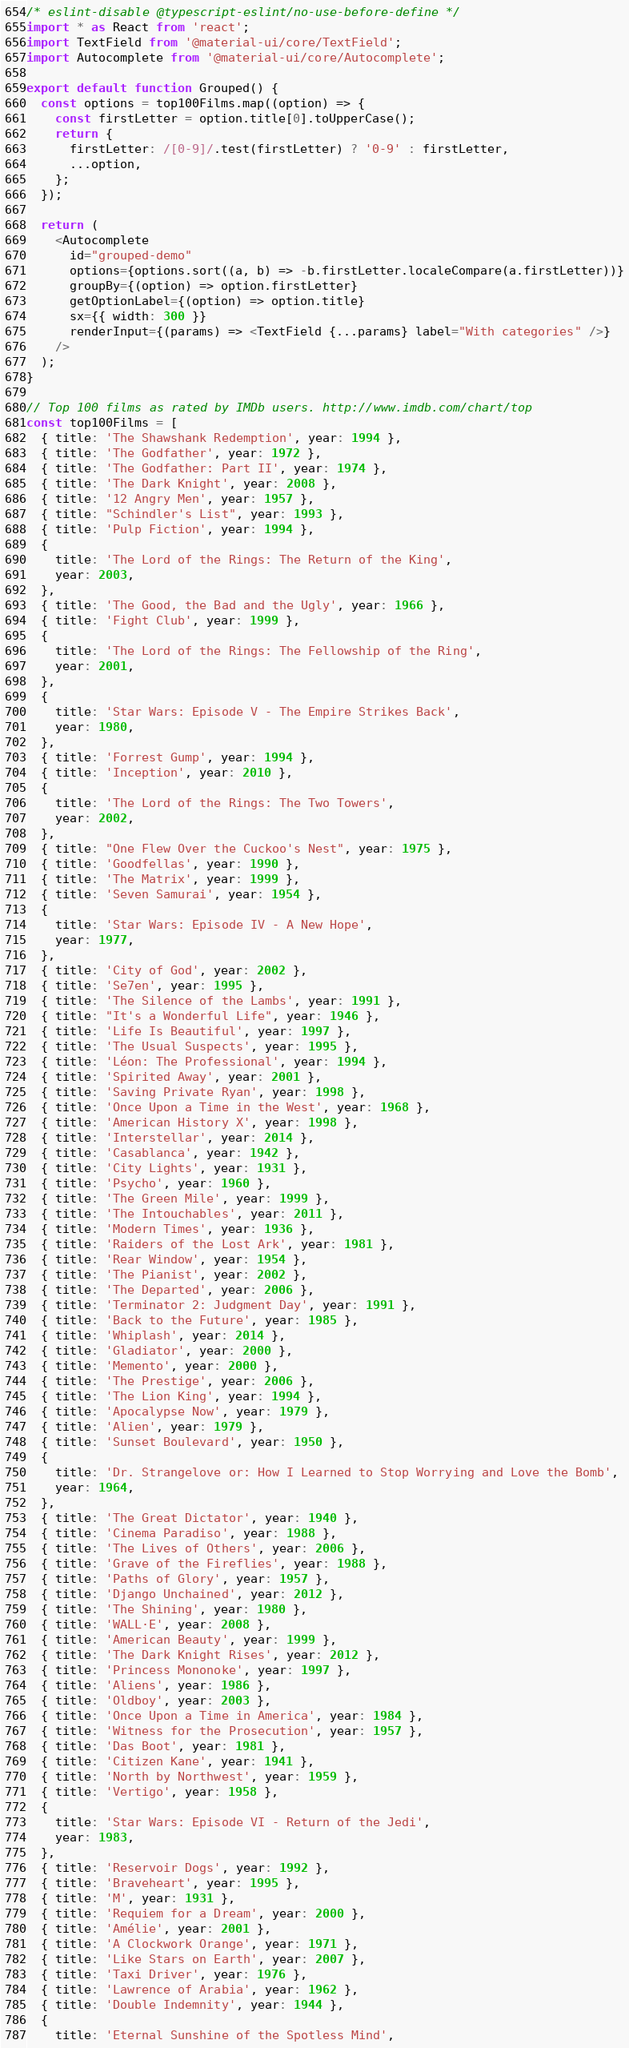Convert code to text. <code><loc_0><loc_0><loc_500><loc_500><_TypeScript_>/* eslint-disable @typescript-eslint/no-use-before-define */
import * as React from 'react';
import TextField from '@material-ui/core/TextField';
import Autocomplete from '@material-ui/core/Autocomplete';

export default function Grouped() {
  const options = top100Films.map((option) => {
    const firstLetter = option.title[0].toUpperCase();
    return {
      firstLetter: /[0-9]/.test(firstLetter) ? '0-9' : firstLetter,
      ...option,
    };
  });

  return (
    <Autocomplete
      id="grouped-demo"
      options={options.sort((a, b) => -b.firstLetter.localeCompare(a.firstLetter))}
      groupBy={(option) => option.firstLetter}
      getOptionLabel={(option) => option.title}
      sx={{ width: 300 }}
      renderInput={(params) => <TextField {...params} label="With categories" />}
    />
  );
}

// Top 100 films as rated by IMDb users. http://www.imdb.com/chart/top
const top100Films = [
  { title: 'The Shawshank Redemption', year: 1994 },
  { title: 'The Godfather', year: 1972 },
  { title: 'The Godfather: Part II', year: 1974 },
  { title: 'The Dark Knight', year: 2008 },
  { title: '12 Angry Men', year: 1957 },
  { title: "Schindler's List", year: 1993 },
  { title: 'Pulp Fiction', year: 1994 },
  {
    title: 'The Lord of the Rings: The Return of the King',
    year: 2003,
  },
  { title: 'The Good, the Bad and the Ugly', year: 1966 },
  { title: 'Fight Club', year: 1999 },
  {
    title: 'The Lord of the Rings: The Fellowship of the Ring',
    year: 2001,
  },
  {
    title: 'Star Wars: Episode V - The Empire Strikes Back',
    year: 1980,
  },
  { title: 'Forrest Gump', year: 1994 },
  { title: 'Inception', year: 2010 },
  {
    title: 'The Lord of the Rings: The Two Towers',
    year: 2002,
  },
  { title: "One Flew Over the Cuckoo's Nest", year: 1975 },
  { title: 'Goodfellas', year: 1990 },
  { title: 'The Matrix', year: 1999 },
  { title: 'Seven Samurai', year: 1954 },
  {
    title: 'Star Wars: Episode IV - A New Hope',
    year: 1977,
  },
  { title: 'City of God', year: 2002 },
  { title: 'Se7en', year: 1995 },
  { title: 'The Silence of the Lambs', year: 1991 },
  { title: "It's a Wonderful Life", year: 1946 },
  { title: 'Life Is Beautiful', year: 1997 },
  { title: 'The Usual Suspects', year: 1995 },
  { title: 'Léon: The Professional', year: 1994 },
  { title: 'Spirited Away', year: 2001 },
  { title: 'Saving Private Ryan', year: 1998 },
  { title: 'Once Upon a Time in the West', year: 1968 },
  { title: 'American History X', year: 1998 },
  { title: 'Interstellar', year: 2014 },
  { title: 'Casablanca', year: 1942 },
  { title: 'City Lights', year: 1931 },
  { title: 'Psycho', year: 1960 },
  { title: 'The Green Mile', year: 1999 },
  { title: 'The Intouchables', year: 2011 },
  { title: 'Modern Times', year: 1936 },
  { title: 'Raiders of the Lost Ark', year: 1981 },
  { title: 'Rear Window', year: 1954 },
  { title: 'The Pianist', year: 2002 },
  { title: 'The Departed', year: 2006 },
  { title: 'Terminator 2: Judgment Day', year: 1991 },
  { title: 'Back to the Future', year: 1985 },
  { title: 'Whiplash', year: 2014 },
  { title: 'Gladiator', year: 2000 },
  { title: 'Memento', year: 2000 },
  { title: 'The Prestige', year: 2006 },
  { title: 'The Lion King', year: 1994 },
  { title: 'Apocalypse Now', year: 1979 },
  { title: 'Alien', year: 1979 },
  { title: 'Sunset Boulevard', year: 1950 },
  {
    title: 'Dr. Strangelove or: How I Learned to Stop Worrying and Love the Bomb',
    year: 1964,
  },
  { title: 'The Great Dictator', year: 1940 },
  { title: 'Cinema Paradiso', year: 1988 },
  { title: 'The Lives of Others', year: 2006 },
  { title: 'Grave of the Fireflies', year: 1988 },
  { title: 'Paths of Glory', year: 1957 },
  { title: 'Django Unchained', year: 2012 },
  { title: 'The Shining', year: 1980 },
  { title: 'WALL·E', year: 2008 },
  { title: 'American Beauty', year: 1999 },
  { title: 'The Dark Knight Rises', year: 2012 },
  { title: 'Princess Mononoke', year: 1997 },
  { title: 'Aliens', year: 1986 },
  { title: 'Oldboy', year: 2003 },
  { title: 'Once Upon a Time in America', year: 1984 },
  { title: 'Witness for the Prosecution', year: 1957 },
  { title: 'Das Boot', year: 1981 },
  { title: 'Citizen Kane', year: 1941 },
  { title: 'North by Northwest', year: 1959 },
  { title: 'Vertigo', year: 1958 },
  {
    title: 'Star Wars: Episode VI - Return of the Jedi',
    year: 1983,
  },
  { title: 'Reservoir Dogs', year: 1992 },
  { title: 'Braveheart', year: 1995 },
  { title: 'M', year: 1931 },
  { title: 'Requiem for a Dream', year: 2000 },
  { title: 'Amélie', year: 2001 },
  { title: 'A Clockwork Orange', year: 1971 },
  { title: 'Like Stars on Earth', year: 2007 },
  { title: 'Taxi Driver', year: 1976 },
  { title: 'Lawrence of Arabia', year: 1962 },
  { title: 'Double Indemnity', year: 1944 },
  {
    title: 'Eternal Sunshine of the Spotless Mind',</code> 